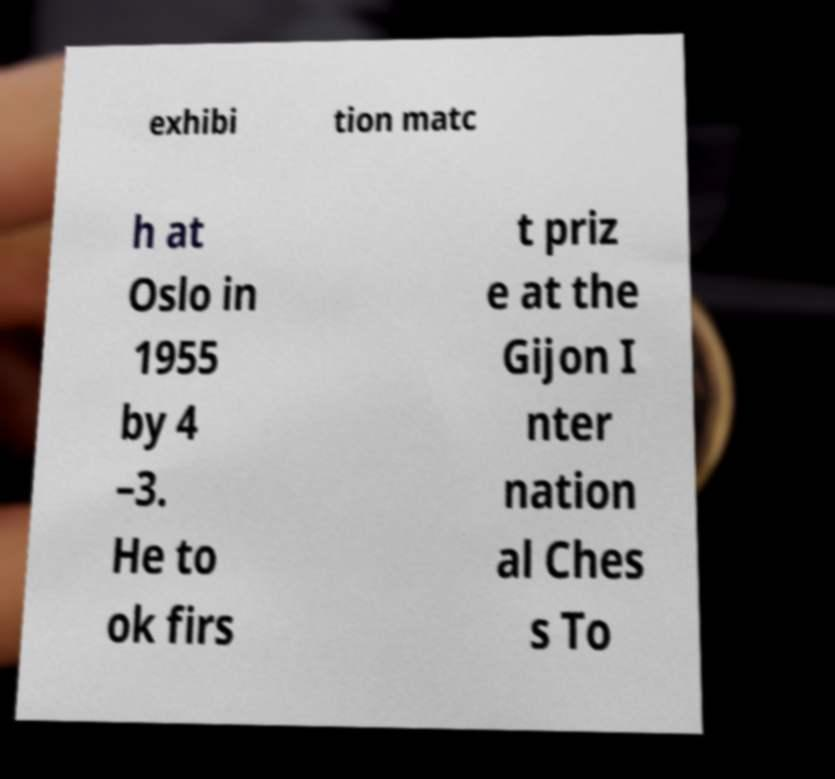For documentation purposes, I need the text within this image transcribed. Could you provide that? exhibi tion matc h at Oslo in 1955 by 4 –3. He to ok firs t priz e at the Gijon I nter nation al Ches s To 